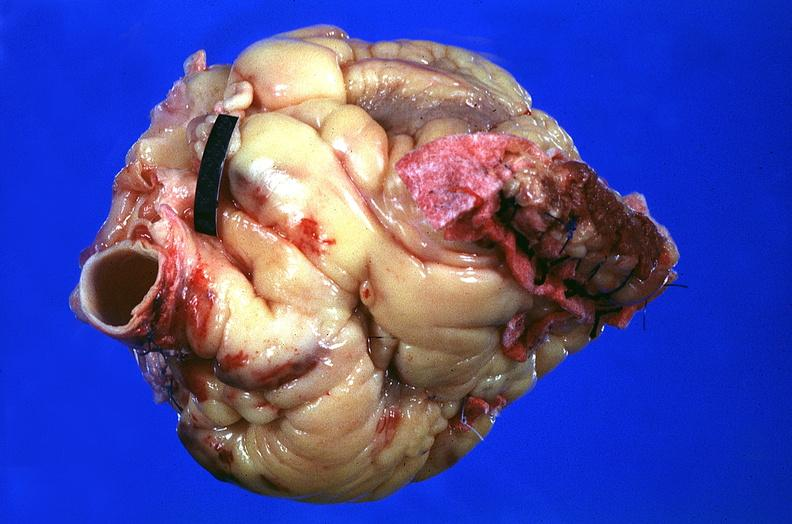what does this image show?
Answer the question using a single word or phrase. Heart 